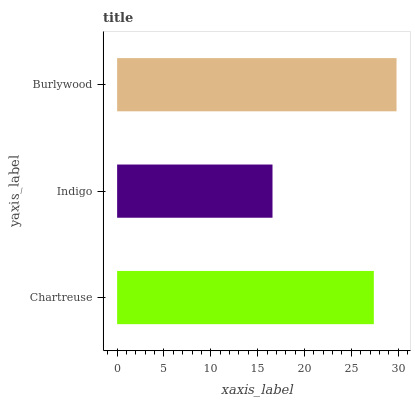Is Indigo the minimum?
Answer yes or no. Yes. Is Burlywood the maximum?
Answer yes or no. Yes. Is Burlywood the minimum?
Answer yes or no. No. Is Indigo the maximum?
Answer yes or no. No. Is Burlywood greater than Indigo?
Answer yes or no. Yes. Is Indigo less than Burlywood?
Answer yes or no. Yes. Is Indigo greater than Burlywood?
Answer yes or no. No. Is Burlywood less than Indigo?
Answer yes or no. No. Is Chartreuse the high median?
Answer yes or no. Yes. Is Chartreuse the low median?
Answer yes or no. Yes. Is Indigo the high median?
Answer yes or no. No. Is Indigo the low median?
Answer yes or no. No. 